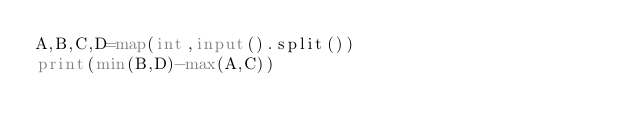Convert code to text. <code><loc_0><loc_0><loc_500><loc_500><_Python_>A,B,C,D=map(int,input().split())
print(min(B,D)-max(A,C))</code> 